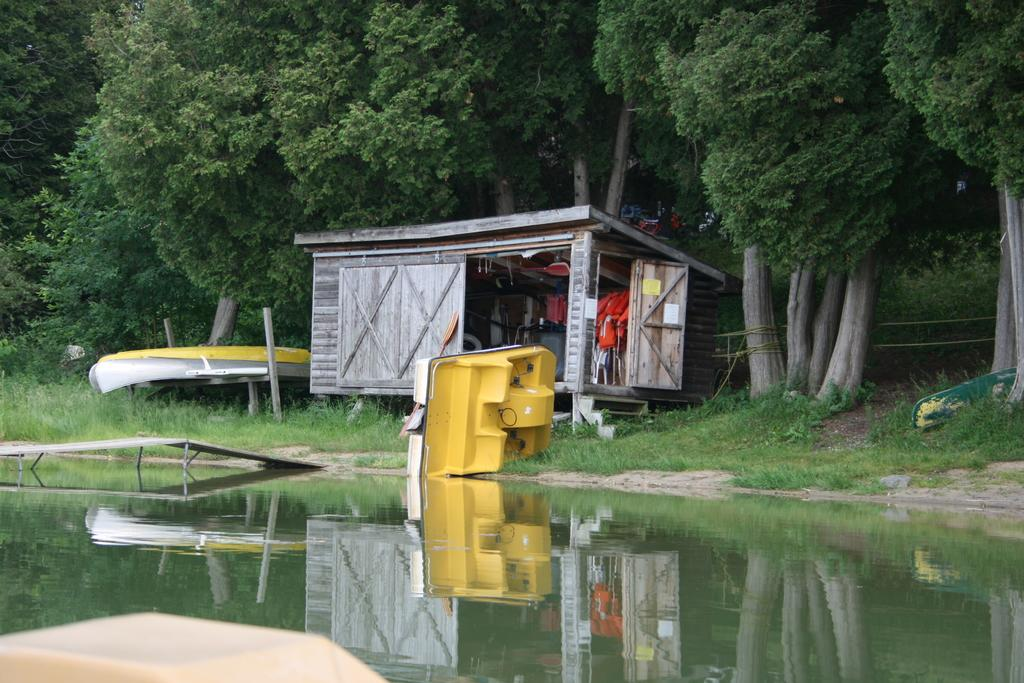What is the main feature of the image? There is water in the image. What is floating on the water? There is a boat in the image. What structure can be seen near the water? There is a shed in the image. What is inside the shed? The shed contains items. What type of vegetation is present in the image? There are trees in the image. What type of barrier is visible in the image? There is a fence in the image. Are there any other objects or features in the image? Yes, there are other objects in the image. What type of jeans is the cow wearing in the image? There is no cow or jeans present in the image. 